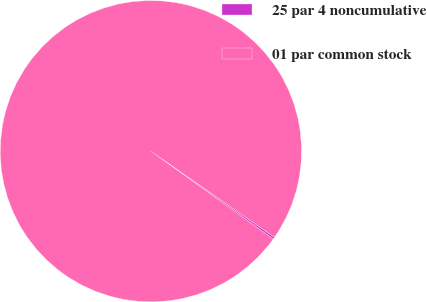Convert chart to OTSL. <chart><loc_0><loc_0><loc_500><loc_500><pie_chart><fcel>25 par 4 noncumulative<fcel>01 par common stock<nl><fcel>0.22%<fcel>99.78%<nl></chart> 